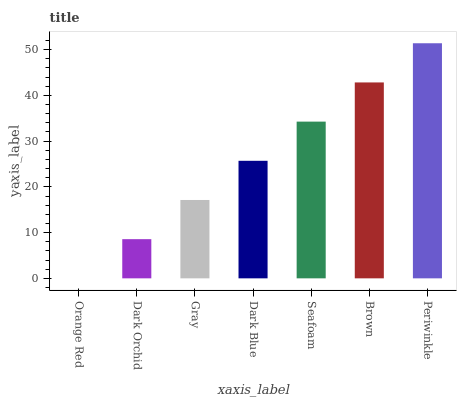Is Dark Orchid the minimum?
Answer yes or no. No. Is Dark Orchid the maximum?
Answer yes or no. No. Is Dark Orchid greater than Orange Red?
Answer yes or no. Yes. Is Orange Red less than Dark Orchid?
Answer yes or no. Yes. Is Orange Red greater than Dark Orchid?
Answer yes or no. No. Is Dark Orchid less than Orange Red?
Answer yes or no. No. Is Dark Blue the high median?
Answer yes or no. Yes. Is Dark Blue the low median?
Answer yes or no. Yes. Is Gray the high median?
Answer yes or no. No. Is Brown the low median?
Answer yes or no. No. 